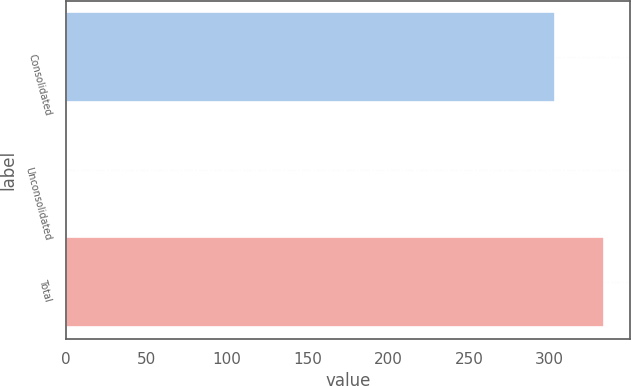Convert chart to OTSL. <chart><loc_0><loc_0><loc_500><loc_500><bar_chart><fcel>Consolidated<fcel>Unconsolidated<fcel>Total<nl><fcel>303<fcel>1<fcel>333.3<nl></chart> 